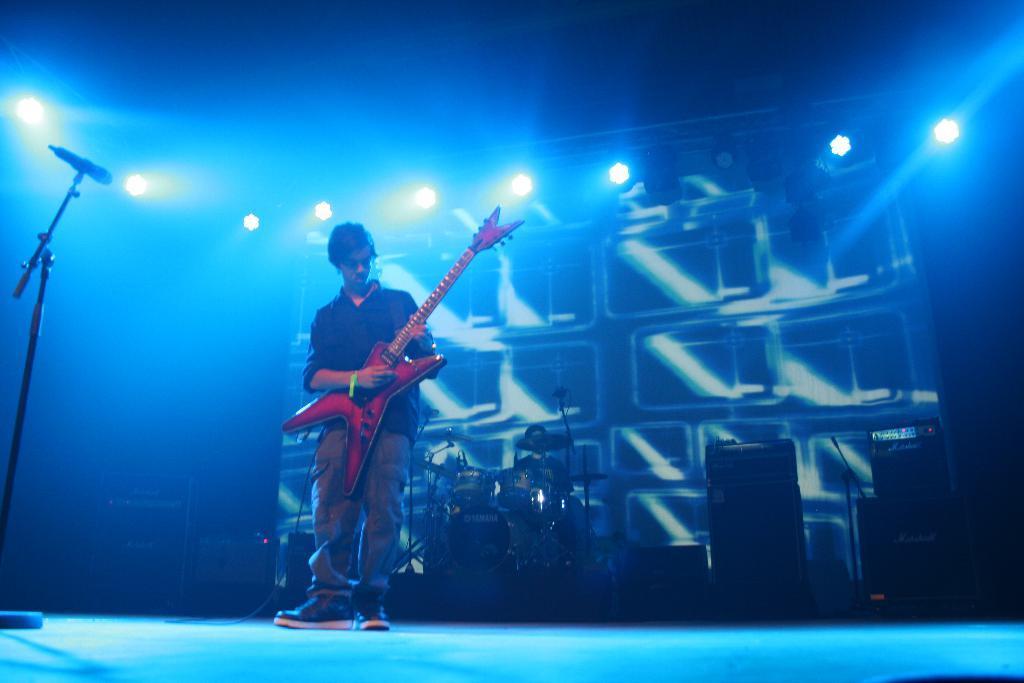Please provide a concise description of this image. In this image I can see a person standing and holding a musical instrument, in front I can see a microphone. Background I can see few musical instruments and I can also see few lights. 